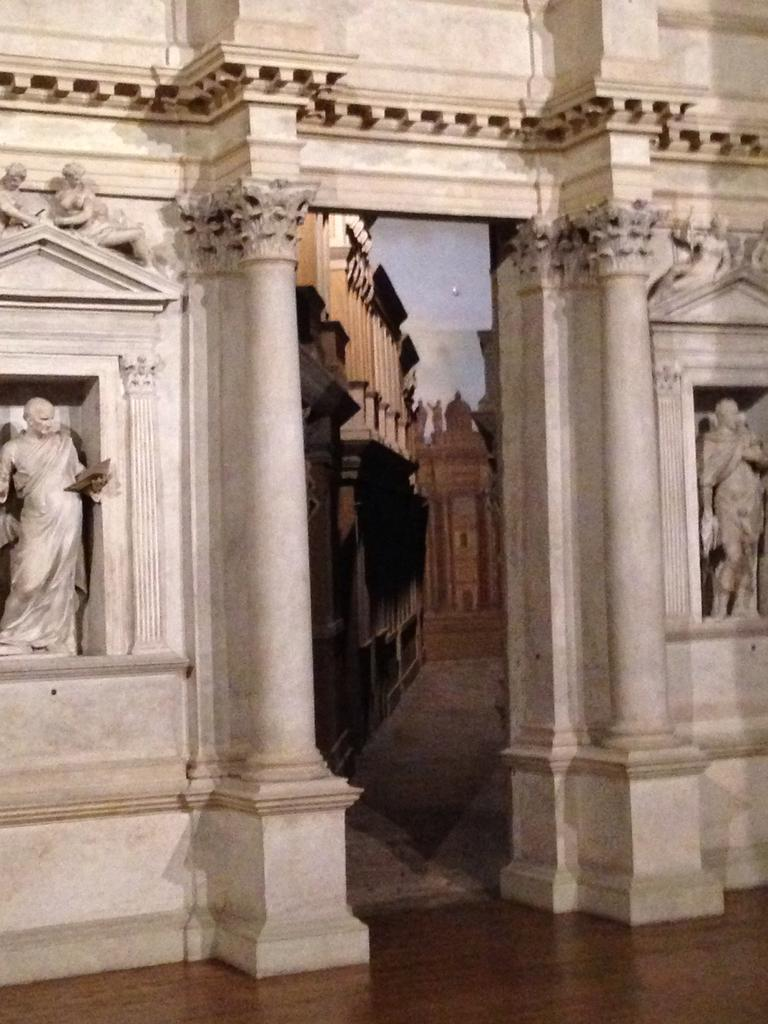What is on the wall in the image? There is a sculpture on the wall in the image. What can be seen below the wall in the image? The ground is visible in the image. What architectural features are present in the image? There are pillars in the image. How many feet are visible in the image? There are no feet visible in the image. What event is taking place in the middle of the image? There is no event taking place in the image; it is a still image of a sculpture, ground, and pillars. 